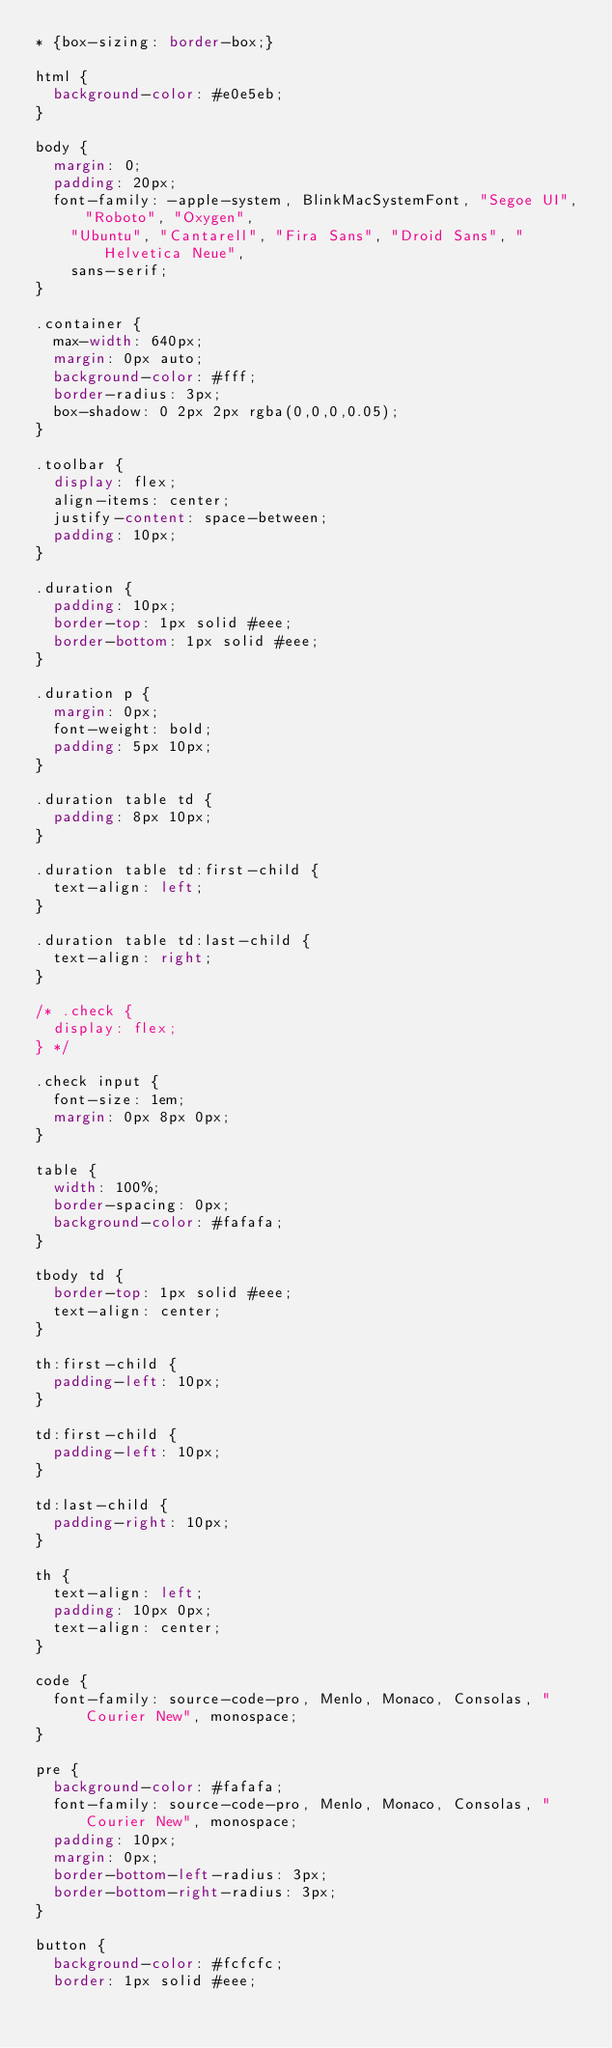Convert code to text. <code><loc_0><loc_0><loc_500><loc_500><_CSS_>* {box-sizing: border-box;}

html {
  background-color: #e0e5eb;
}

body {
  margin: 0;
  padding: 20px;
  font-family: -apple-system, BlinkMacSystemFont, "Segoe UI", "Roboto", "Oxygen",
    "Ubuntu", "Cantarell", "Fira Sans", "Droid Sans", "Helvetica Neue",
    sans-serif;
}

.container {
  max-width: 640px;
  margin: 0px auto;
  background-color: #fff;
  border-radius: 3px;
  box-shadow: 0 2px 2px rgba(0,0,0,0.05);
}

.toolbar {
  display: flex;
  align-items: center;
  justify-content: space-between;
  padding: 10px;
}

.duration {
  padding: 10px;
  border-top: 1px solid #eee;
  border-bottom: 1px solid #eee;
}

.duration p {
  margin: 0px;
  font-weight: bold;
  padding: 5px 10px;
}

.duration table td {
  padding: 8px 10px;
}

.duration table td:first-child {
  text-align: left;
}

.duration table td:last-child {
  text-align: right;
}

/* .check {
  display: flex;
} */

.check input {
  font-size: 1em;
  margin: 0px 8px 0px;
}

table {
  width: 100%;
  border-spacing: 0px;
  background-color: #fafafa;
}

tbody td {
  border-top: 1px solid #eee;
  text-align: center;
}

th:first-child {
  padding-left: 10px;
}

td:first-child {
  padding-left: 10px;
}

td:last-child {
  padding-right: 10px;
}

th {
  text-align: left;
  padding: 10px 0px;
  text-align: center;
}

code {
  font-family: source-code-pro, Menlo, Monaco, Consolas, "Courier New", monospace;
}

pre {
  background-color: #fafafa;
  font-family: source-code-pro, Menlo, Monaco, Consolas, "Courier New", monospace;
  padding: 10px;
  margin: 0px;
  border-bottom-left-radius: 3px;
  border-bottom-right-radius: 3px;
}

button {
  background-color: #fcfcfc;
  border: 1px solid #eee;</code> 